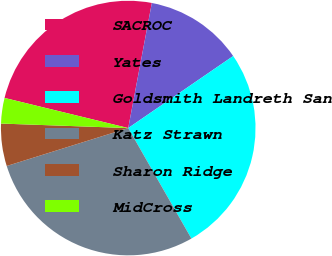<chart> <loc_0><loc_0><loc_500><loc_500><pie_chart><fcel>SACROC<fcel>Yates<fcel>Goldsmith Landreth San<fcel>Katz Strawn<fcel>Sharon Ridge<fcel>MidCross<nl><fcel>24.17%<fcel>12.46%<fcel>26.31%<fcel>28.45%<fcel>5.38%<fcel>3.24%<nl></chart> 